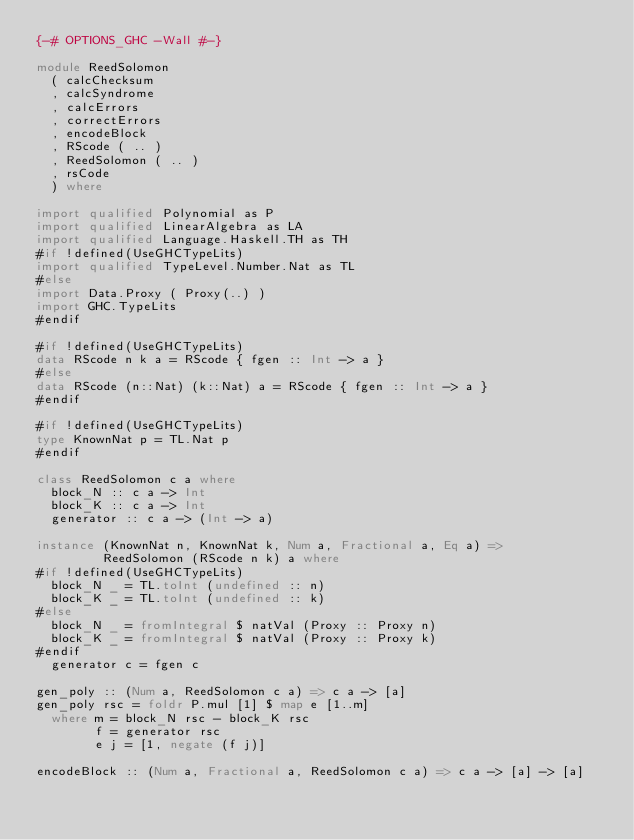Convert code to text. <code><loc_0><loc_0><loc_500><loc_500><_Haskell_>{-# OPTIONS_GHC -Wall #-}

module ReedSolomon
  ( calcChecksum
  , calcSyndrome
  , calcErrors
  , correctErrors
  , encodeBlock
  , RScode ( .. )
  , ReedSolomon ( .. )
  , rsCode
  ) where

import qualified Polynomial as P
import qualified LinearAlgebra as LA
import qualified Language.Haskell.TH as TH
#if !defined(UseGHCTypeLits)
import qualified TypeLevel.Number.Nat as TL
#else
import Data.Proxy ( Proxy(..) )
import GHC.TypeLits
#endif

#if !defined(UseGHCTypeLits)
data RScode n k a = RScode { fgen :: Int -> a }
#else
data RScode (n::Nat) (k::Nat) a = RScode { fgen :: Int -> a }
#endif

#if !defined(UseGHCTypeLits)
type KnownNat p = TL.Nat p
#endif

class ReedSolomon c a where
  block_N :: c a -> Int
  block_K :: c a -> Int
  generator :: c a -> (Int -> a)

instance (KnownNat n, KnownNat k, Num a, Fractional a, Eq a) =>
         ReedSolomon (RScode n k) a where
#if !defined(UseGHCTypeLits)
  block_N _ = TL.toInt (undefined :: n)
  block_K _ = TL.toInt (undefined :: k)
#else
  block_N _ = fromIntegral $ natVal (Proxy :: Proxy n)
  block_K _ = fromIntegral $ natVal (Proxy :: Proxy k)
#endif
  generator c = fgen c

gen_poly :: (Num a, ReedSolomon c a) => c a -> [a]
gen_poly rsc = foldr P.mul [1] $ map e [1..m]
  where m = block_N rsc - block_K rsc
        f = generator rsc
        e j = [1, negate (f j)]

encodeBlock :: (Num a, Fractional a, ReedSolomon c a) => c a -> [a] -> [a]</code> 